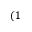Convert formula to latex. <formula><loc_0><loc_0><loc_500><loc_500>( 1</formula> 